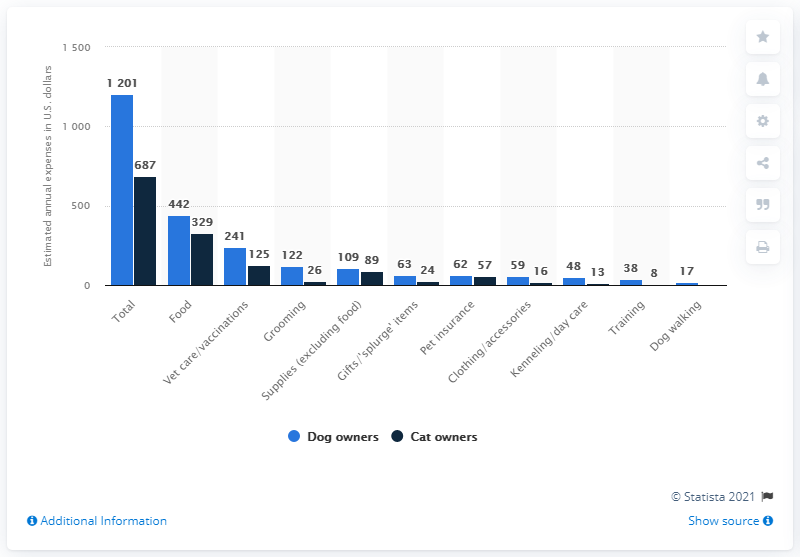Indicate a few pertinent items in this graphic. According to a survey, cat owners typically spend an average of $329 per year on pet food. In 2020, dog owners spent an estimated $442 on pet food per year, on average. 